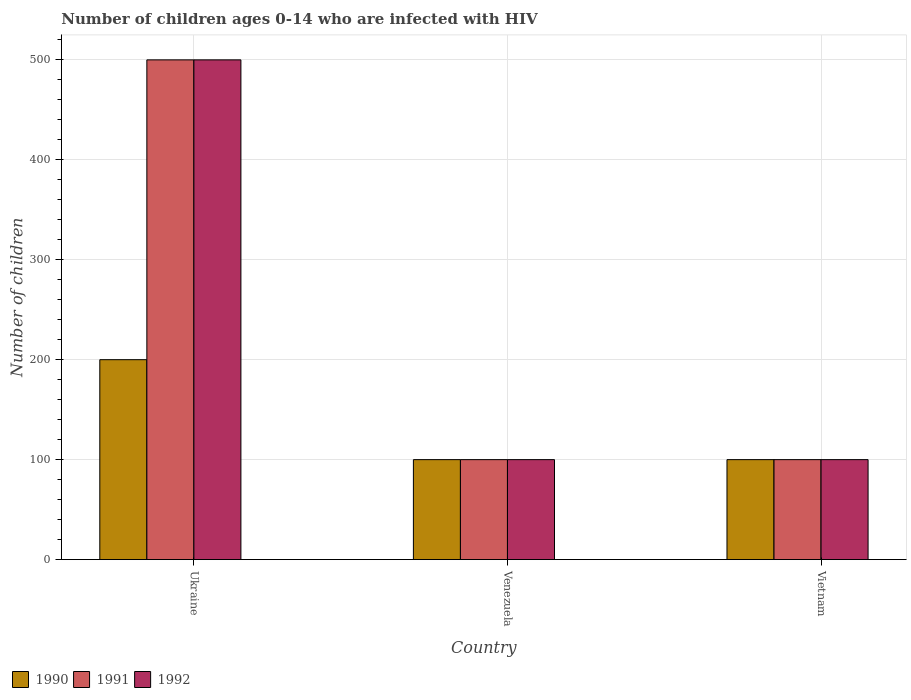Are the number of bars per tick equal to the number of legend labels?
Offer a terse response. Yes. Are the number of bars on each tick of the X-axis equal?
Provide a succinct answer. Yes. How many bars are there on the 3rd tick from the right?
Offer a terse response. 3. What is the label of the 3rd group of bars from the left?
Offer a terse response. Vietnam. What is the number of HIV infected children in 1992 in Ukraine?
Provide a succinct answer. 500. Across all countries, what is the maximum number of HIV infected children in 1992?
Your answer should be compact. 500. Across all countries, what is the minimum number of HIV infected children in 1992?
Provide a short and direct response. 100. In which country was the number of HIV infected children in 1990 maximum?
Your response must be concise. Ukraine. In which country was the number of HIV infected children in 1990 minimum?
Make the answer very short. Venezuela. What is the total number of HIV infected children in 1990 in the graph?
Provide a short and direct response. 400. What is the average number of HIV infected children in 1991 per country?
Make the answer very short. 233.33. What is the difference between the number of HIV infected children of/in 1990 and number of HIV infected children of/in 1992 in Ukraine?
Ensure brevity in your answer.  -300. What is the difference between the highest and the second highest number of HIV infected children in 1991?
Give a very brief answer. -400. What is the difference between the highest and the lowest number of HIV infected children in 1990?
Give a very brief answer. 100. In how many countries, is the number of HIV infected children in 1990 greater than the average number of HIV infected children in 1990 taken over all countries?
Offer a very short reply. 1. What does the 1st bar from the left in Venezuela represents?
Make the answer very short. 1990. What does the 2nd bar from the right in Ukraine represents?
Your answer should be compact. 1991. Is it the case that in every country, the sum of the number of HIV infected children in 1991 and number of HIV infected children in 1990 is greater than the number of HIV infected children in 1992?
Your response must be concise. Yes. Are all the bars in the graph horizontal?
Your answer should be very brief. No. How many countries are there in the graph?
Give a very brief answer. 3. Does the graph contain any zero values?
Make the answer very short. No. Where does the legend appear in the graph?
Your answer should be compact. Bottom left. How many legend labels are there?
Your answer should be compact. 3. How are the legend labels stacked?
Your response must be concise. Horizontal. What is the title of the graph?
Make the answer very short. Number of children ages 0-14 who are infected with HIV. What is the label or title of the Y-axis?
Give a very brief answer. Number of children. What is the Number of children in 1990 in Ukraine?
Your answer should be compact. 200. What is the Number of children in 1992 in Ukraine?
Offer a terse response. 500. What is the Number of children of 1990 in Venezuela?
Your answer should be very brief. 100. What is the Number of children in 1991 in Venezuela?
Give a very brief answer. 100. What is the Number of children in 1992 in Venezuela?
Give a very brief answer. 100. What is the Number of children in 1990 in Vietnam?
Provide a short and direct response. 100. What is the Number of children in 1992 in Vietnam?
Your answer should be very brief. 100. Across all countries, what is the maximum Number of children of 1990?
Give a very brief answer. 200. Across all countries, what is the maximum Number of children of 1991?
Offer a terse response. 500. What is the total Number of children of 1990 in the graph?
Your response must be concise. 400. What is the total Number of children of 1991 in the graph?
Your answer should be compact. 700. What is the total Number of children in 1992 in the graph?
Give a very brief answer. 700. What is the difference between the Number of children of 1990 in Ukraine and that in Venezuela?
Offer a terse response. 100. What is the difference between the Number of children in 1990 in Ukraine and that in Vietnam?
Give a very brief answer. 100. What is the difference between the Number of children of 1992 in Ukraine and that in Vietnam?
Provide a succinct answer. 400. What is the difference between the Number of children in 1991 in Venezuela and that in Vietnam?
Give a very brief answer. 0. What is the difference between the Number of children in 1992 in Venezuela and that in Vietnam?
Ensure brevity in your answer.  0. What is the difference between the Number of children of 1990 in Ukraine and the Number of children of 1992 in Venezuela?
Provide a succinct answer. 100. What is the difference between the Number of children in 1991 in Ukraine and the Number of children in 1992 in Venezuela?
Provide a succinct answer. 400. What is the difference between the Number of children in 1991 in Ukraine and the Number of children in 1992 in Vietnam?
Provide a short and direct response. 400. What is the difference between the Number of children of 1990 in Venezuela and the Number of children of 1992 in Vietnam?
Provide a short and direct response. 0. What is the average Number of children in 1990 per country?
Provide a short and direct response. 133.33. What is the average Number of children of 1991 per country?
Provide a succinct answer. 233.33. What is the average Number of children of 1992 per country?
Give a very brief answer. 233.33. What is the difference between the Number of children in 1990 and Number of children in 1991 in Ukraine?
Your response must be concise. -300. What is the difference between the Number of children of 1990 and Number of children of 1992 in Ukraine?
Provide a short and direct response. -300. What is the difference between the Number of children of 1990 and Number of children of 1991 in Vietnam?
Provide a succinct answer. 0. What is the difference between the Number of children in 1990 and Number of children in 1992 in Vietnam?
Your response must be concise. 0. What is the difference between the Number of children in 1991 and Number of children in 1992 in Vietnam?
Provide a short and direct response. 0. What is the ratio of the Number of children in 1990 in Ukraine to that in Venezuela?
Make the answer very short. 2. What is the ratio of the Number of children of 1991 in Ukraine to that in Venezuela?
Provide a short and direct response. 5. What is the ratio of the Number of children in 1991 in Ukraine to that in Vietnam?
Make the answer very short. 5. What is the ratio of the Number of children in 1990 in Venezuela to that in Vietnam?
Your answer should be compact. 1. What is the ratio of the Number of children in 1991 in Venezuela to that in Vietnam?
Keep it short and to the point. 1. What is the difference between the highest and the second highest Number of children in 1990?
Make the answer very short. 100. What is the difference between the highest and the second highest Number of children of 1991?
Offer a very short reply. 400. What is the difference between the highest and the lowest Number of children in 1990?
Ensure brevity in your answer.  100. What is the difference between the highest and the lowest Number of children of 1991?
Your answer should be very brief. 400. 